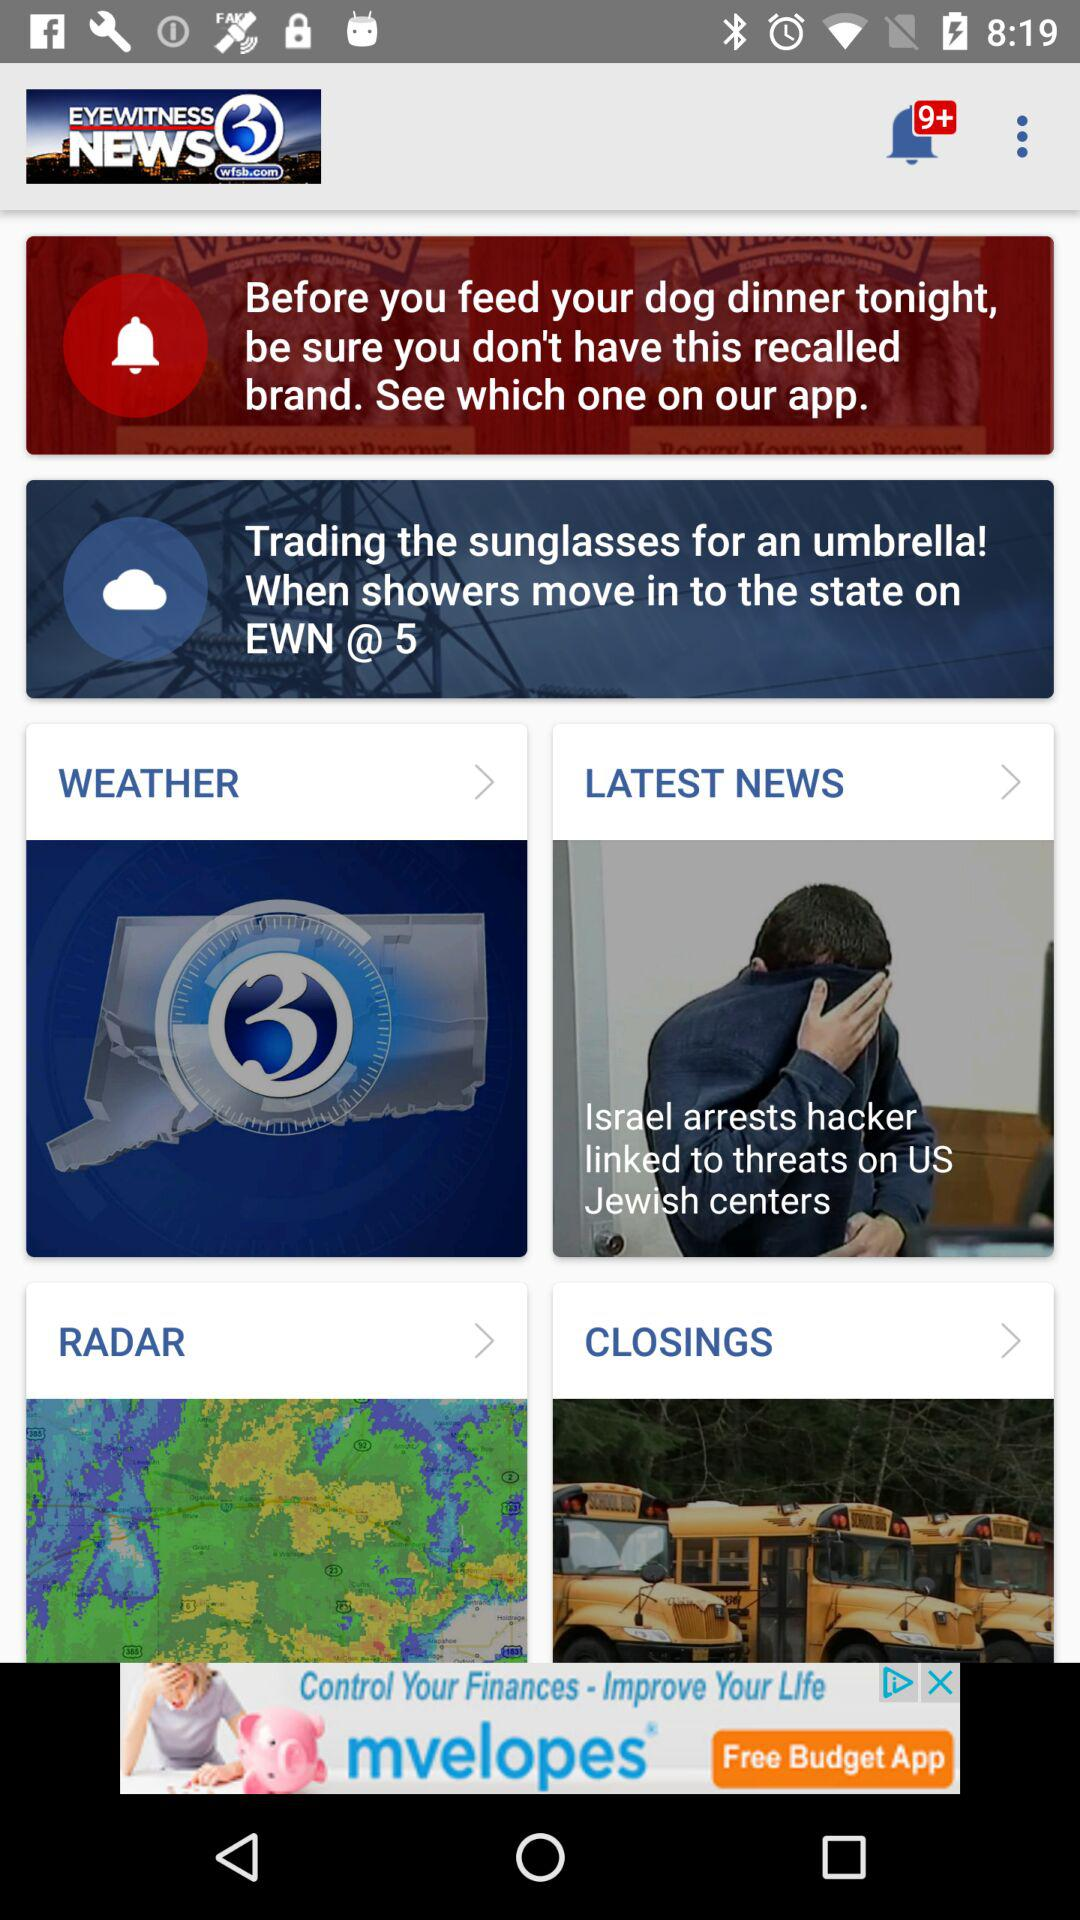What are the different kinds of news that are displayed? The different kinds of news are "WEATHER", "LATEST NEWS", "RADAR" and "CLOSINGS". 